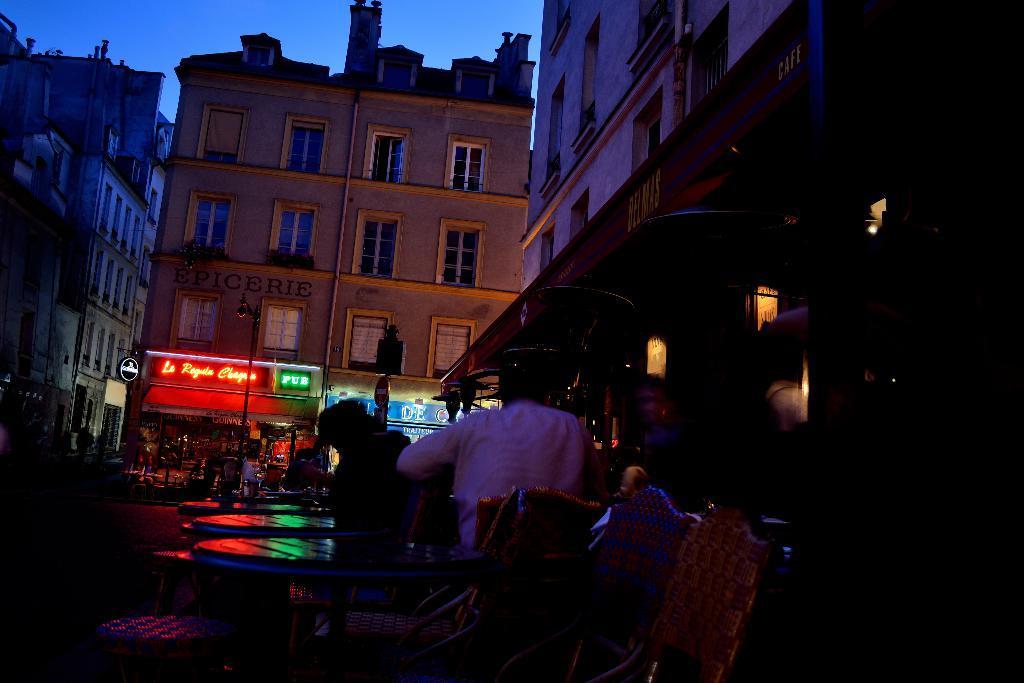Please provide a concise description of this image. This is looking like a busy street, There are buildings around the place. Few people are there on the street. This is night time. There are hoardings in front of the shop. 